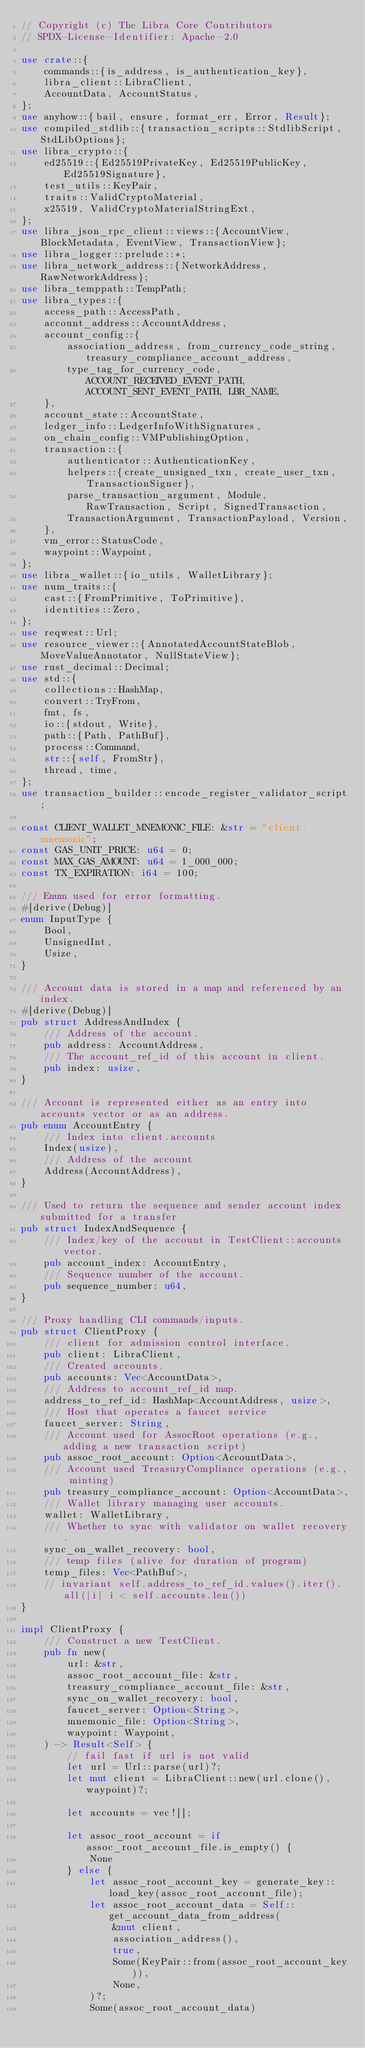Convert code to text. <code><loc_0><loc_0><loc_500><loc_500><_Rust_>// Copyright (c) The Libra Core Contributors
// SPDX-License-Identifier: Apache-2.0

use crate::{
    commands::{is_address, is_authentication_key},
    libra_client::LibraClient,
    AccountData, AccountStatus,
};
use anyhow::{bail, ensure, format_err, Error, Result};
use compiled_stdlib::{transaction_scripts::StdlibScript, StdLibOptions};
use libra_crypto::{
    ed25519::{Ed25519PrivateKey, Ed25519PublicKey, Ed25519Signature},
    test_utils::KeyPair,
    traits::ValidCryptoMaterial,
    x25519, ValidCryptoMaterialStringExt,
};
use libra_json_rpc_client::views::{AccountView, BlockMetadata, EventView, TransactionView};
use libra_logger::prelude::*;
use libra_network_address::{NetworkAddress, RawNetworkAddress};
use libra_temppath::TempPath;
use libra_types::{
    access_path::AccessPath,
    account_address::AccountAddress,
    account_config::{
        association_address, from_currency_code_string, treasury_compliance_account_address,
        type_tag_for_currency_code, ACCOUNT_RECEIVED_EVENT_PATH, ACCOUNT_SENT_EVENT_PATH, LBR_NAME,
    },
    account_state::AccountState,
    ledger_info::LedgerInfoWithSignatures,
    on_chain_config::VMPublishingOption,
    transaction::{
        authenticator::AuthenticationKey,
        helpers::{create_unsigned_txn, create_user_txn, TransactionSigner},
        parse_transaction_argument, Module, RawTransaction, Script, SignedTransaction,
        TransactionArgument, TransactionPayload, Version,
    },
    vm_error::StatusCode,
    waypoint::Waypoint,
};
use libra_wallet::{io_utils, WalletLibrary};
use num_traits::{
    cast::{FromPrimitive, ToPrimitive},
    identities::Zero,
};
use reqwest::Url;
use resource_viewer::{AnnotatedAccountStateBlob, MoveValueAnnotator, NullStateView};
use rust_decimal::Decimal;
use std::{
    collections::HashMap,
    convert::TryFrom,
    fmt, fs,
    io::{stdout, Write},
    path::{Path, PathBuf},
    process::Command,
    str::{self, FromStr},
    thread, time,
};
use transaction_builder::encode_register_validator_script;

const CLIENT_WALLET_MNEMONIC_FILE: &str = "client.mnemonic";
const GAS_UNIT_PRICE: u64 = 0;
const MAX_GAS_AMOUNT: u64 = 1_000_000;
const TX_EXPIRATION: i64 = 100;

/// Enum used for error formatting.
#[derive(Debug)]
enum InputType {
    Bool,
    UnsignedInt,
    Usize,
}

/// Account data is stored in a map and referenced by an index.
#[derive(Debug)]
pub struct AddressAndIndex {
    /// Address of the account.
    pub address: AccountAddress,
    /// The account_ref_id of this account in client.
    pub index: usize,
}

/// Account is represented either as an entry into accounts vector or as an address.
pub enum AccountEntry {
    /// Index into client.accounts
    Index(usize),
    /// Address of the account
    Address(AccountAddress),
}

/// Used to return the sequence and sender account index submitted for a transfer
pub struct IndexAndSequence {
    /// Index/key of the account in TestClient::accounts vector.
    pub account_index: AccountEntry,
    /// Sequence number of the account.
    pub sequence_number: u64,
}

/// Proxy handling CLI commands/inputs.
pub struct ClientProxy {
    /// client for admission control interface.
    pub client: LibraClient,
    /// Created accounts.
    pub accounts: Vec<AccountData>,
    /// Address to account_ref_id map.
    address_to_ref_id: HashMap<AccountAddress, usize>,
    /// Host that operates a faucet service
    faucet_server: String,
    /// Account used for AssocRoot operations (e.g., adding a new transaction script)
    pub assoc_root_account: Option<AccountData>,
    /// Account used TreasuryCompliance operations (e.g., minting)
    pub treasury_compliance_account: Option<AccountData>,
    /// Wallet library managing user accounts.
    wallet: WalletLibrary,
    /// Whether to sync with validator on wallet recovery.
    sync_on_wallet_recovery: bool,
    /// temp files (alive for duration of program)
    temp_files: Vec<PathBuf>,
    // invariant self.address_to_ref_id.values().iter().all(|i| i < self.accounts.len())
}

impl ClientProxy {
    /// Construct a new TestClient.
    pub fn new(
        url: &str,
        assoc_root_account_file: &str,
        treasury_compliance_account_file: &str,
        sync_on_wallet_recovery: bool,
        faucet_server: Option<String>,
        mnemonic_file: Option<String>,
        waypoint: Waypoint,
    ) -> Result<Self> {
        // fail fast if url is not valid
        let url = Url::parse(url)?;
        let mut client = LibraClient::new(url.clone(), waypoint)?;

        let accounts = vec![];

        let assoc_root_account = if assoc_root_account_file.is_empty() {
            None
        } else {
            let assoc_root_account_key = generate_key::load_key(assoc_root_account_file);
            let assoc_root_account_data = Self::get_account_data_from_address(
                &mut client,
                association_address(),
                true,
                Some(KeyPair::from(assoc_root_account_key)),
                None,
            )?;
            Some(assoc_root_account_data)</code> 